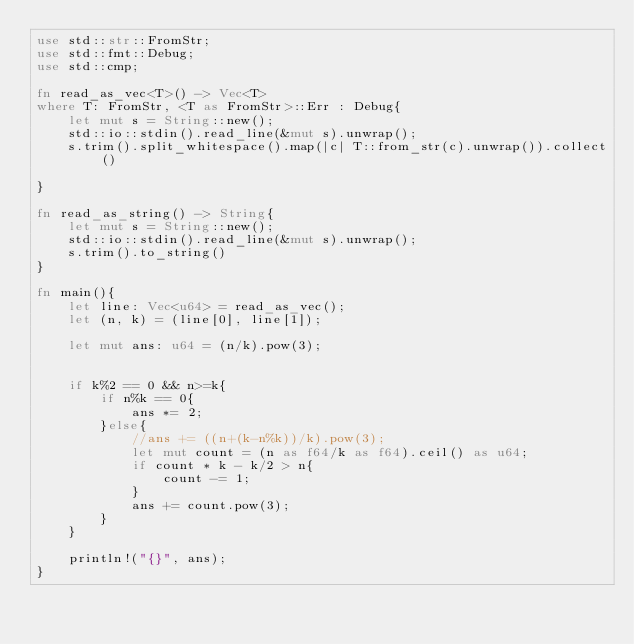Convert code to text. <code><loc_0><loc_0><loc_500><loc_500><_Rust_>use std::str::FromStr;
use std::fmt::Debug;
use std::cmp;

fn read_as_vec<T>() -> Vec<T>
where T: FromStr, <T as FromStr>::Err : Debug{
    let mut s = String::new();
    std::io::stdin().read_line(&mut s).unwrap();
    s.trim().split_whitespace().map(|c| T::from_str(c).unwrap()).collect()

}

fn read_as_string() -> String{
    let mut s = String::new();
    std::io::stdin().read_line(&mut s).unwrap();
    s.trim().to_string()
}

fn main(){
    let line: Vec<u64> = read_as_vec();
    let (n, k) = (line[0], line[1]);
    
    let mut ans: u64 = (n/k).pow(3);


    if k%2 == 0 && n>=k{
        if n%k == 0{
            ans *= 2;
        }else{
            //ans += ((n+(k-n%k))/k).pow(3);
            let mut count = (n as f64/k as f64).ceil() as u64;
            if count * k - k/2 > n{
                count -= 1;
            }
            ans += count.pow(3);
        }
    }

    println!("{}", ans);
}
</code> 